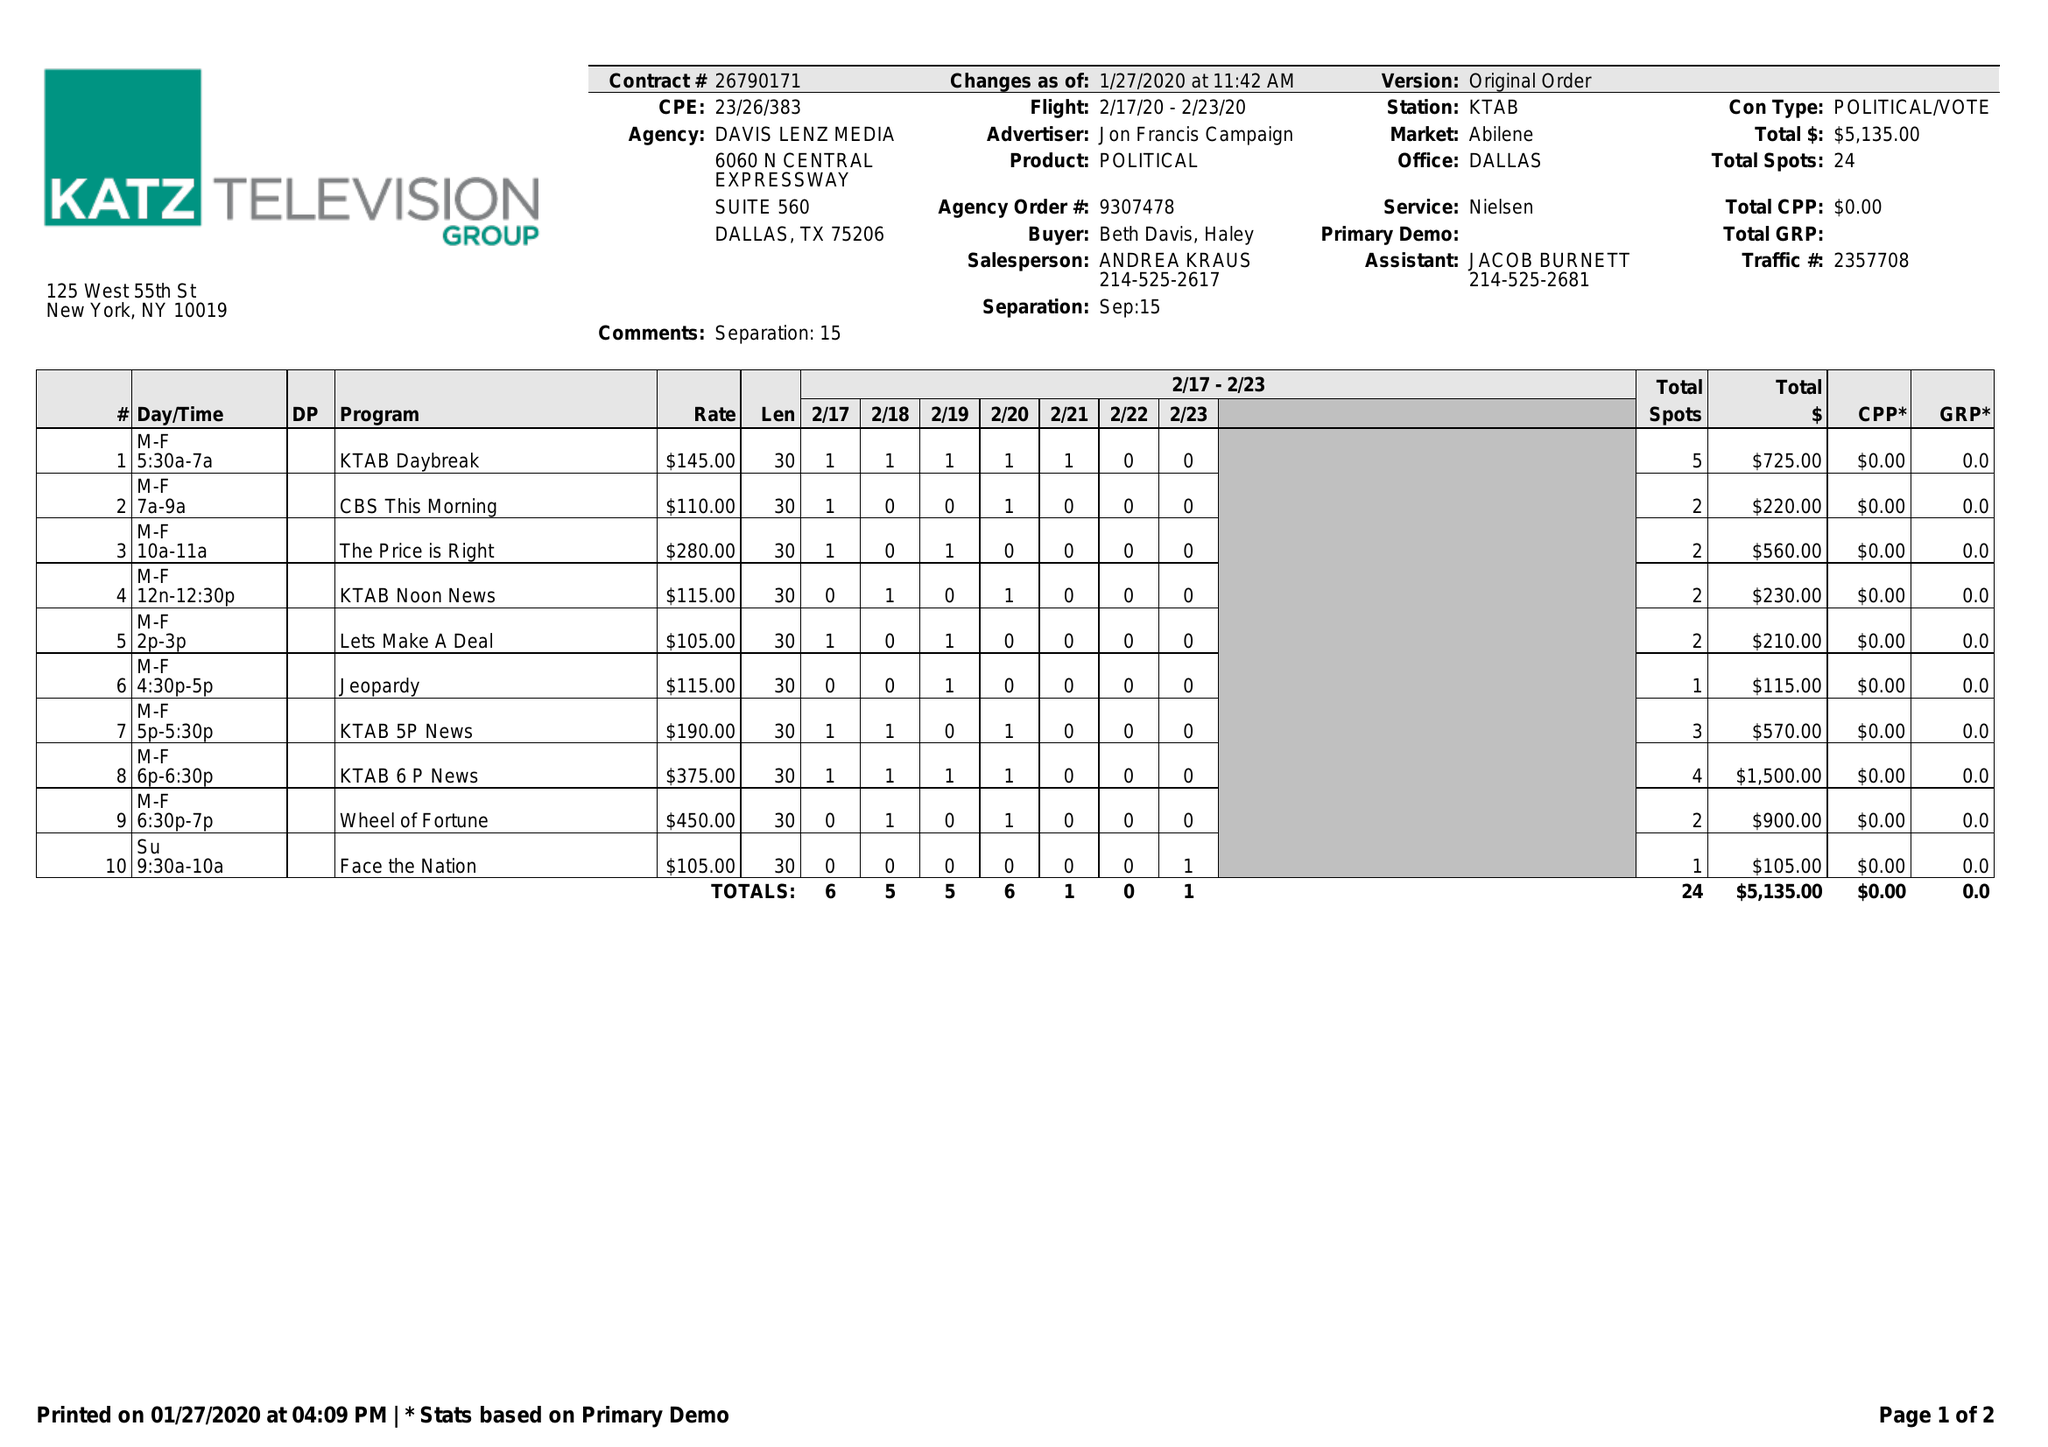What is the value for the flight_to?
Answer the question using a single word or phrase. 02/23/20 